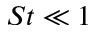Convert formula to latex. <formula><loc_0><loc_0><loc_500><loc_500>S t \ll 1</formula> 